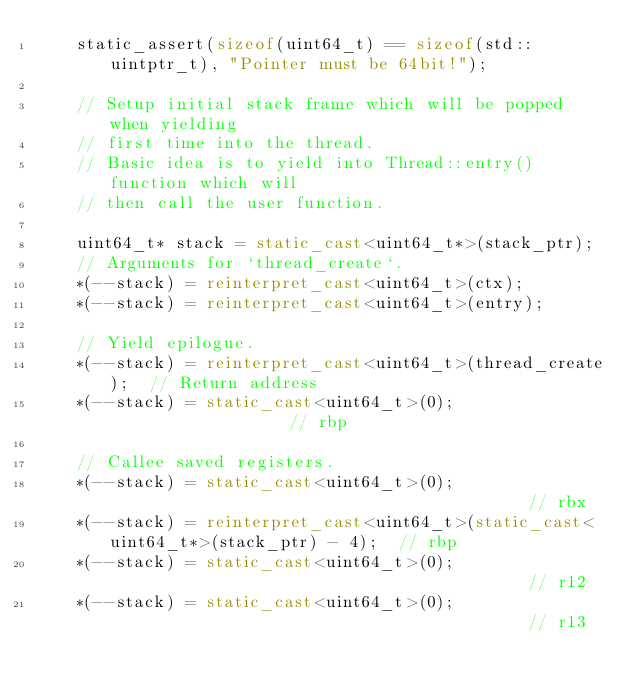Convert code to text. <code><loc_0><loc_0><loc_500><loc_500><_C++_>    static_assert(sizeof(uint64_t) == sizeof(std::uintptr_t), "Pointer must be 64bit!");

    // Setup initial stack frame which will be popped when yielding
    // first time into the thread.
    // Basic idea is to yield into Thread::entry() function which will
    // then call the user function.

    uint64_t* stack = static_cast<uint64_t*>(stack_ptr);
    // Arguments for `thread_create`.
    *(--stack) = reinterpret_cast<uint64_t>(ctx);
    *(--stack) = reinterpret_cast<uint64_t>(entry);

    // Yield epilogue.
    *(--stack) = reinterpret_cast<uint64_t>(thread_create);  // Return address
    *(--stack) = static_cast<uint64_t>(0);                   // rbp

    // Callee saved registers.
    *(--stack) = static_cast<uint64_t>(0);                                           // rbx
    *(--stack) = reinterpret_cast<uint64_t>(static_cast<uint64_t*>(stack_ptr) - 4);  // rbp
    *(--stack) = static_cast<uint64_t>(0);                                           // r12
    *(--stack) = static_cast<uint64_t>(0);                                           // r13</code> 